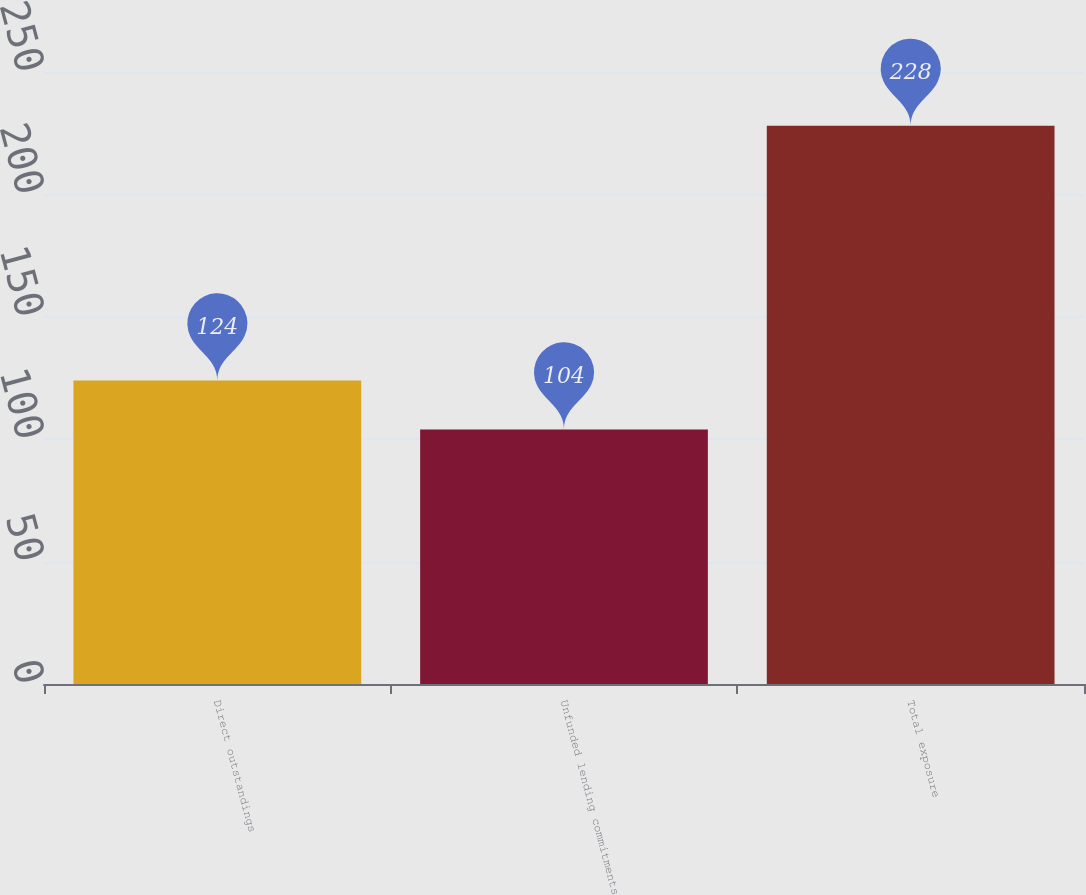Convert chart. <chart><loc_0><loc_0><loc_500><loc_500><bar_chart><fcel>Direct outstandings<fcel>Unfunded lending commitments<fcel>Total exposure<nl><fcel>124<fcel>104<fcel>228<nl></chart> 